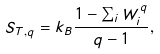Convert formula to latex. <formula><loc_0><loc_0><loc_500><loc_500>S _ { T , q } = k _ { B } \frac { 1 - \sum _ { i } W _ { i } ^ { q } } { q - 1 } ,</formula> 